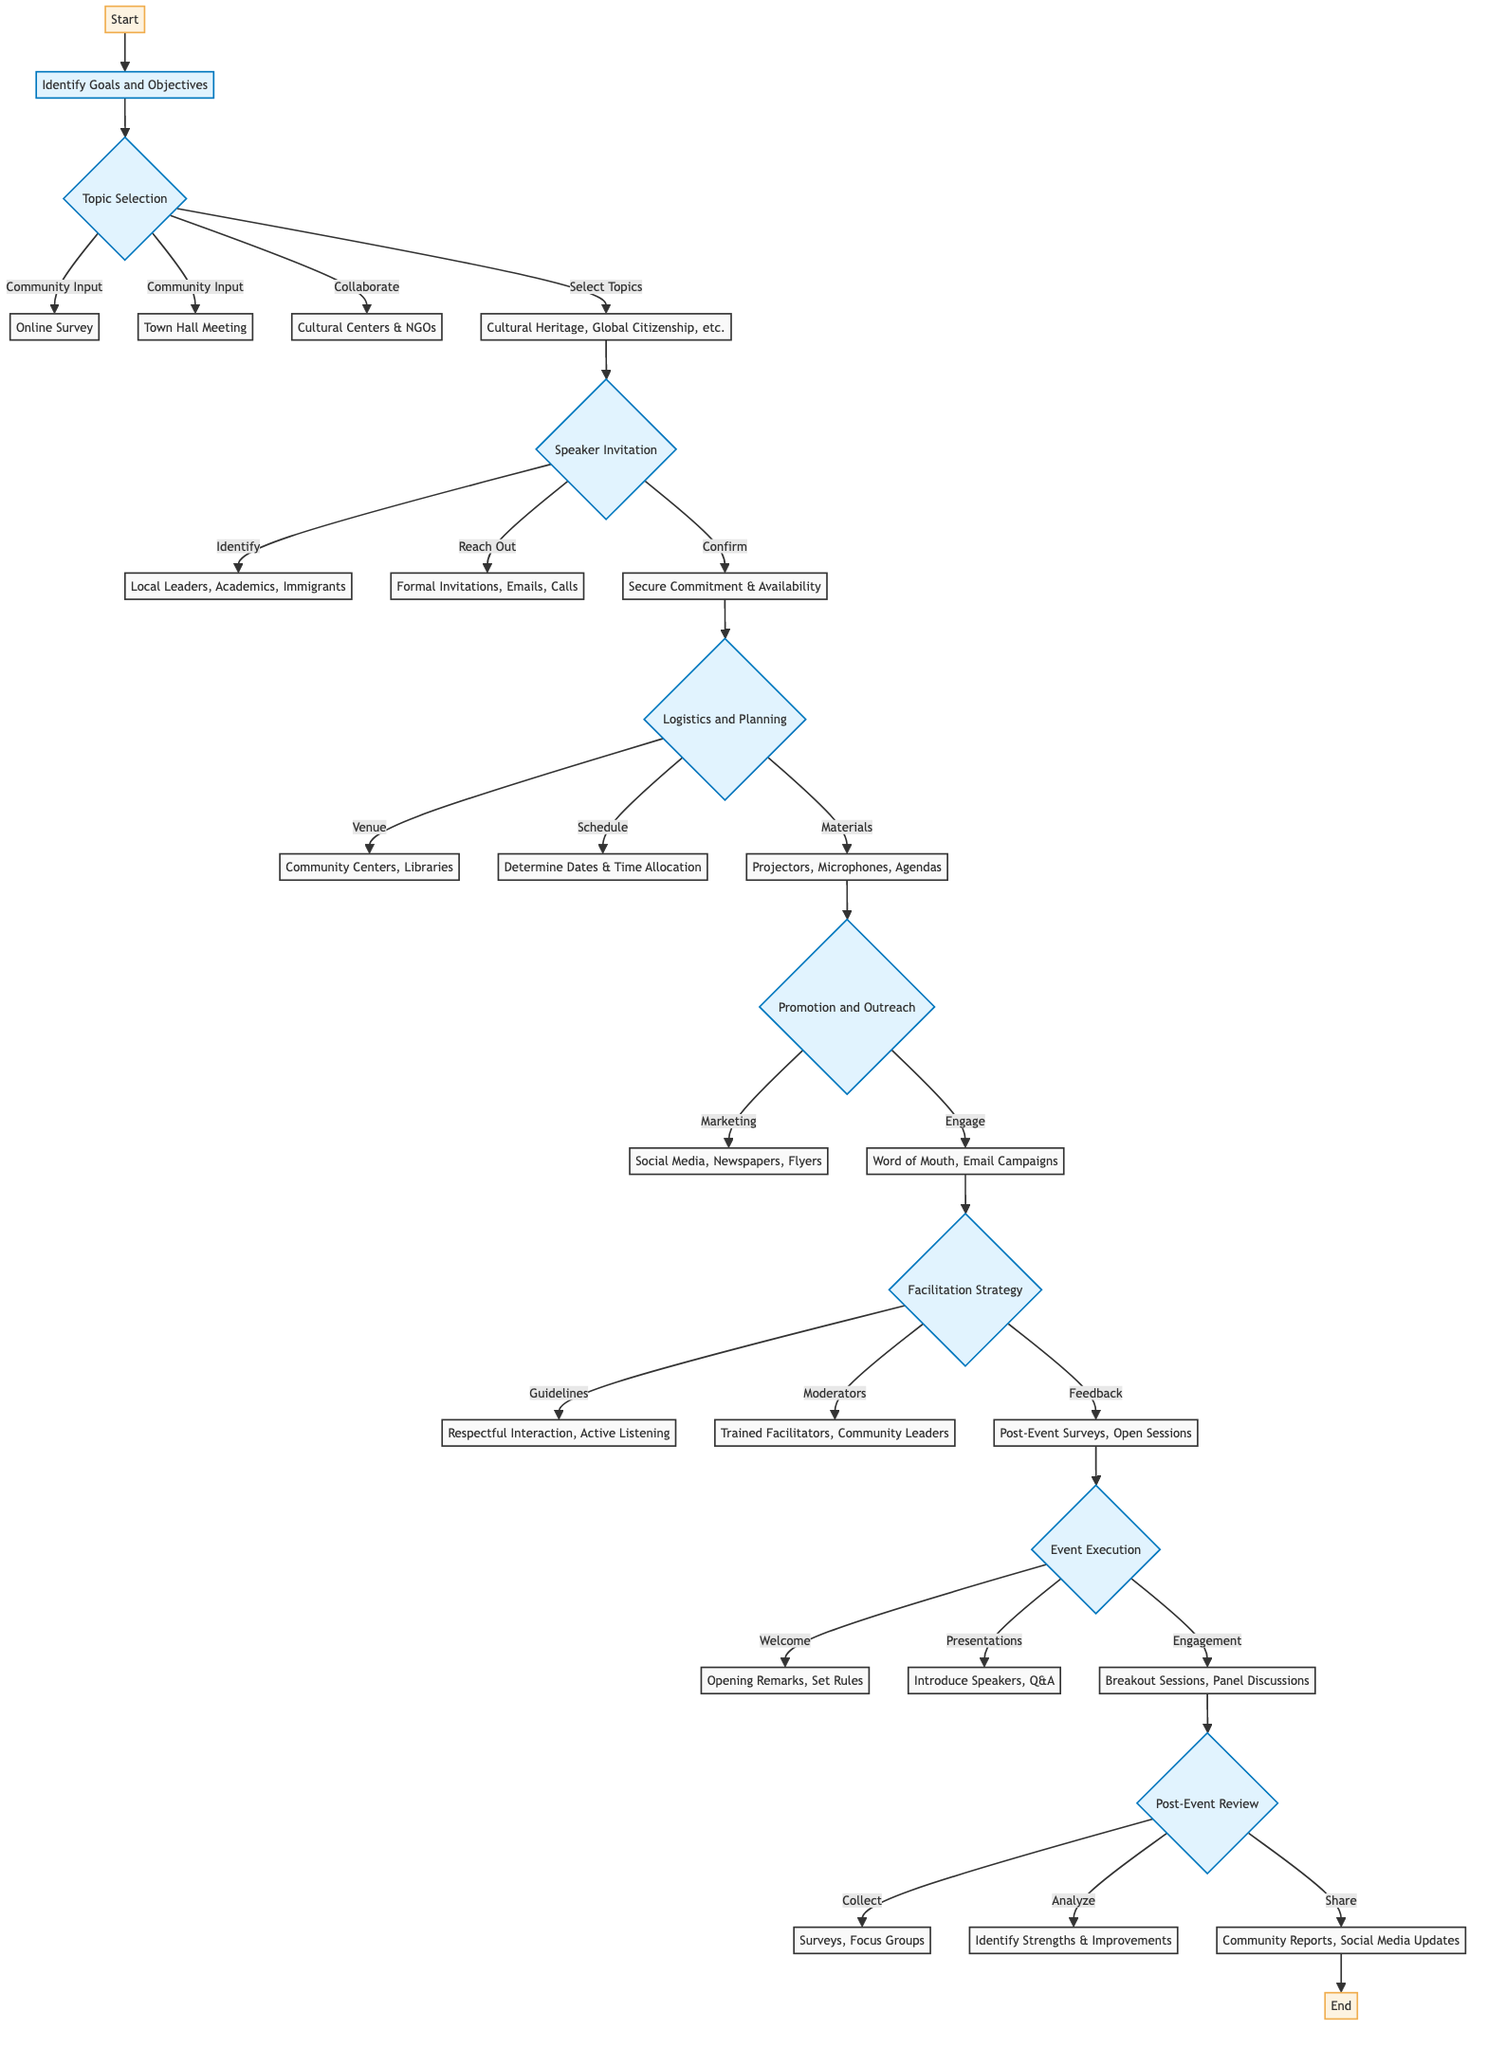What is the first step in the flowchart? The first step in the flowchart is "Identify Goals and Objectives" which is the initial node that leads to further steps in the process.
Answer: Identify Goals and Objectives How many topics are listed under "Select Relevant Topics"? There are four topics listed under "Select Relevant Topics," which are Cultural Heritage, Global Citizenship, Immigrant Experiences, and Interfaith Dialogue.
Answer: 4 Which two methods are used for Community Input? The two methods used for Community Input are "Online Survey" and "Town Hall Meeting," both of which collect input from the community regarding topic selection.
Answer: Online Survey, Town Hall Meeting What are the two marketing channels listed in Promotion and Outreach? The two marketing channels listed in Promotion and Outreach are "Social Media" and "Local Newspapers," which are used to promote the dialogue series to the community.
Answer: Social Media, Local Newspapers What step directly follows "Confirm Participation"? The step that directly follows "Confirm Participation" is "Logistics and Planning," indicating that after speakers are confirmed, logistics needs to be addressed for the event execution.
Answer: Logistics and Planning What does the Facilitation Strategy include as a feedback mechanism? The Facilitation Strategy includes "Post-Event Surveys" and "Open Feedback Sessions" as a feedback mechanism to gather insights from participants after the event.
Answer: Post-Event Surveys, Open Feedback Sessions How many types of engagement strategies are listed under Event Execution? There are three types of engagement strategies listed under Event Execution: "Breakout Sessions," "Panel Discussions," and "Interactive Activities," indicating various ways to engage participants.
Answer: 3 What is the last step of the flowchart? The last step of the flowchart is "End," signifying the conclusion of the process after sharing outcomes from the Post-Event Review stage.
Answer: End Which groups are suggested for inviting as speakers? The suggested groups for inviting as speakers include "Local Leaders," "Academics," "Immigrants," and "Representatives from Nonprofits."
Answer: Local Leaders, Academics, Immigrants, Representatives from Nonprofits What is a component of the logistics planning? A component of the logistics planning includes "Venue Selection," which identifies where the event will be held, essential for successful execution of the event.
Answer: Venue Selection 